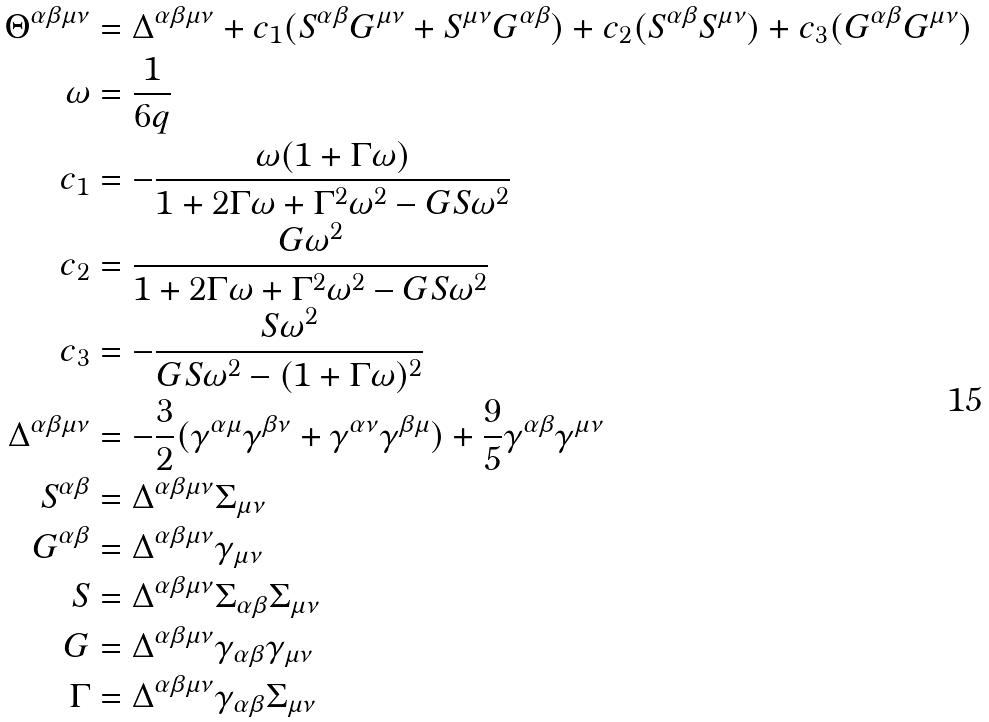Convert formula to latex. <formula><loc_0><loc_0><loc_500><loc_500>\Theta ^ { \alpha \beta \mu \nu } & = \Delta ^ { \alpha \beta \mu \nu } + c _ { 1 } ( S ^ { \alpha \beta } G ^ { \mu \nu } + S ^ { \mu \nu } G ^ { \alpha \beta } ) + c _ { 2 } ( S ^ { \alpha \beta } S ^ { \mu \nu } ) + c _ { 3 } ( G ^ { \alpha \beta } G ^ { \mu \nu } ) \\ \omega & = \frac { 1 } { 6 q } \\ c _ { 1 } & = - \frac { \omega ( 1 + \Gamma \omega ) } { 1 + 2 \Gamma \omega + \Gamma ^ { 2 } \omega ^ { 2 } - G S \omega ^ { 2 } } \\ c _ { 2 } & = \frac { G \omega ^ { 2 } } { 1 + 2 \Gamma \omega + \Gamma ^ { 2 } \omega ^ { 2 } - G S \omega ^ { 2 } } \\ c _ { 3 } & = - \frac { S \omega ^ { 2 } } { G S \omega ^ { 2 } - ( 1 + \Gamma \omega ) ^ { 2 } } \\ \Delta ^ { \alpha \beta \mu \nu } & = - \frac { 3 } { 2 } ( \gamma ^ { \alpha \mu } \gamma ^ { \beta \nu } + \gamma ^ { \alpha \nu } \gamma ^ { \beta \mu } ) + \frac { 9 } { 5 } \gamma ^ { \alpha \beta } \gamma ^ { \mu \nu } \\ S ^ { \alpha \beta } & = \Delta ^ { \alpha \beta \mu \nu } \Sigma _ { \mu \nu } \\ G ^ { \alpha \beta } & = \Delta ^ { \alpha \beta \mu \nu } \gamma _ { \mu \nu } \\ S & = \Delta ^ { \alpha \beta \mu \nu } \Sigma _ { \alpha \beta } \Sigma _ { \mu \nu } \\ G & = \Delta ^ { \alpha \beta \mu \nu } \gamma _ { \alpha \beta } \gamma _ { \mu \nu } \\ \Gamma & = \Delta ^ { \alpha \beta \mu \nu } \gamma _ { \alpha \beta } \Sigma _ { \mu \nu }</formula> 